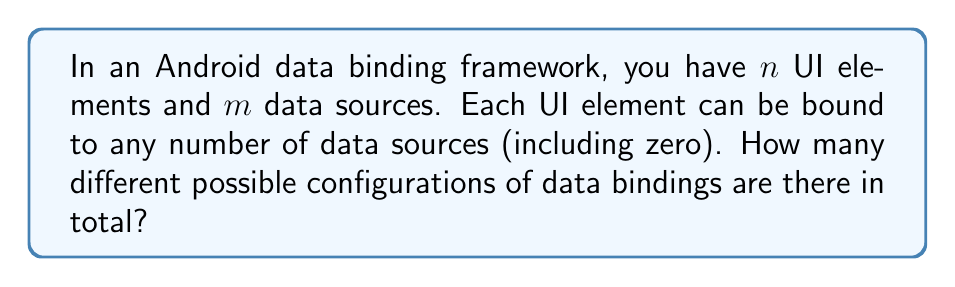Teach me how to tackle this problem. Let's approach this step-by-step:

1) For each UI element, we need to decide which data sources it will be bound to.

2) For each data source, we have two choices for each UI element: either it's bound to that data source, or it's not.

3) This means that for each UI element, we have $2^m$ possible binding configurations (as there are $m$ data sources, and 2 choices for each).

4) Since we have $n$ UI elements, and each can independently have any of these $2^m$ configurations, we can use the multiplication principle.

5) The total number of possible configurations is therefore:

   $$(2^m)^n = 2^{mn}$$

This represents all possible ways to assign bindings between $n$ UI elements and $m$ data sources.
Answer: $2^{mn}$ 